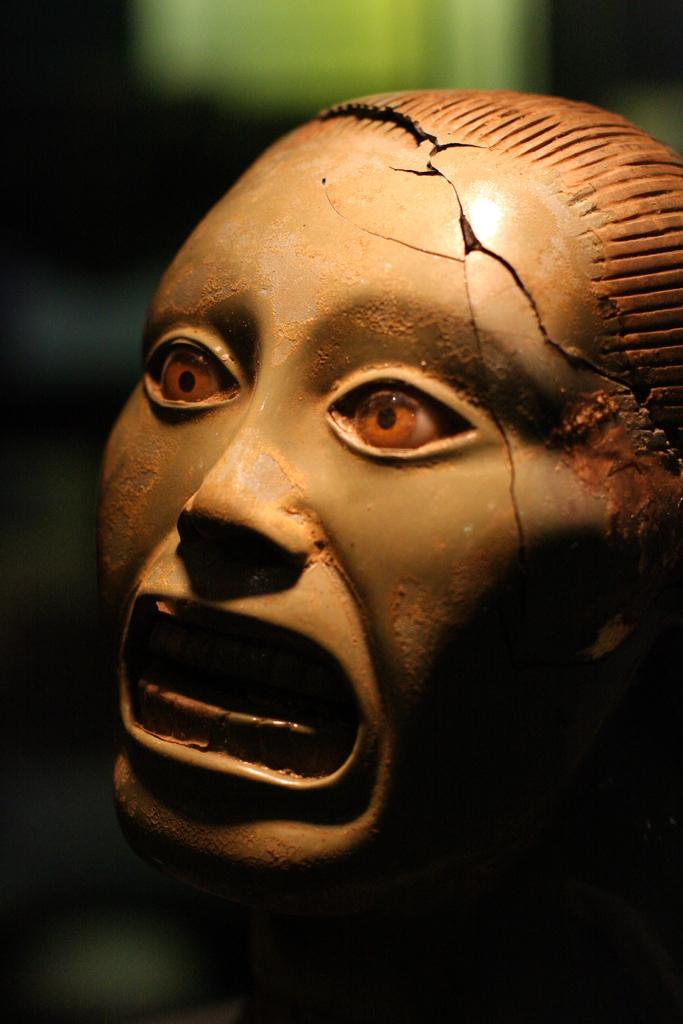What is the main subject of the image? There is a sculpture in the image. What type of disease is affecting the sculpture in the image? There is no mention of a disease affecting the sculpture in the image, and diseases are not applicable to inanimate objects like sculptures. 